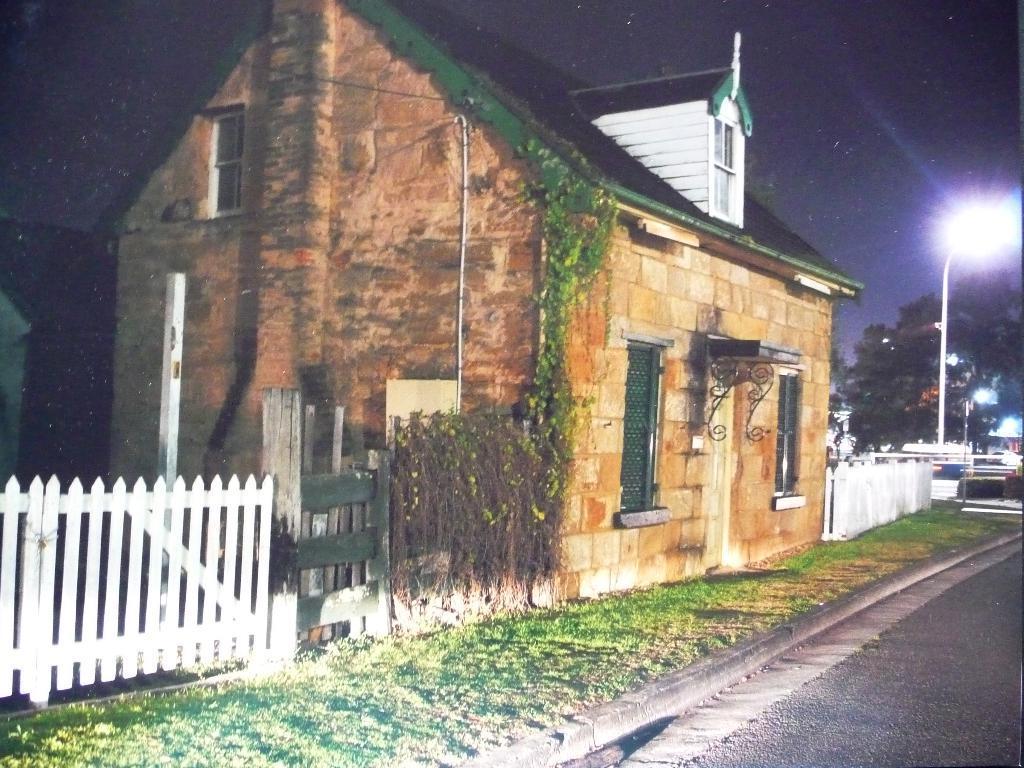Can you describe this image briefly? In this picture we can see the brown color house with the roofing tiles. Beside there is a white color wooden gate. On the right corner we can see some trees and street lights. 